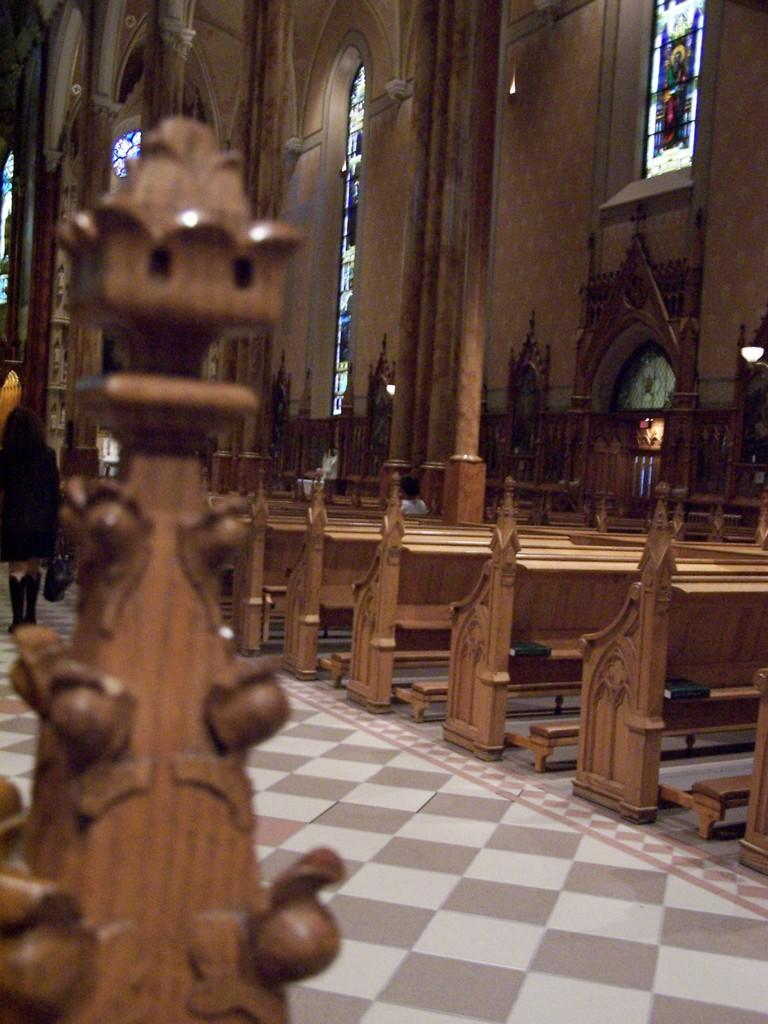What type of seating is visible in the image? There are sitting benches in the image. Can you describe the setting of the image? The setting appears to be inside a church. What type of farm animals can be seen in the image? There are no farm animals present in the image; it is set inside a church. What type of cloth is draped over the benches in the image? There is no cloth draped over the benches in the image; the benches are visible as they are. 